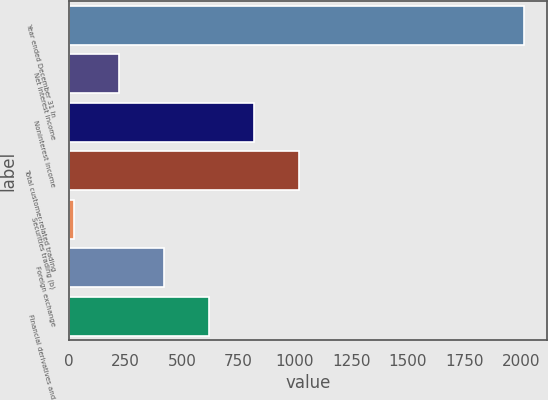Convert chart. <chart><loc_0><loc_0><loc_500><loc_500><bar_chart><fcel>Year ended December 31 In<fcel>Net interest income<fcel>Noninterest income<fcel>Total customer-related trading<fcel>Securities trading (b)<fcel>Foreign exchange<fcel>Financial derivatives and<nl><fcel>2013<fcel>220.2<fcel>817.8<fcel>1017<fcel>21<fcel>419.4<fcel>618.6<nl></chart> 